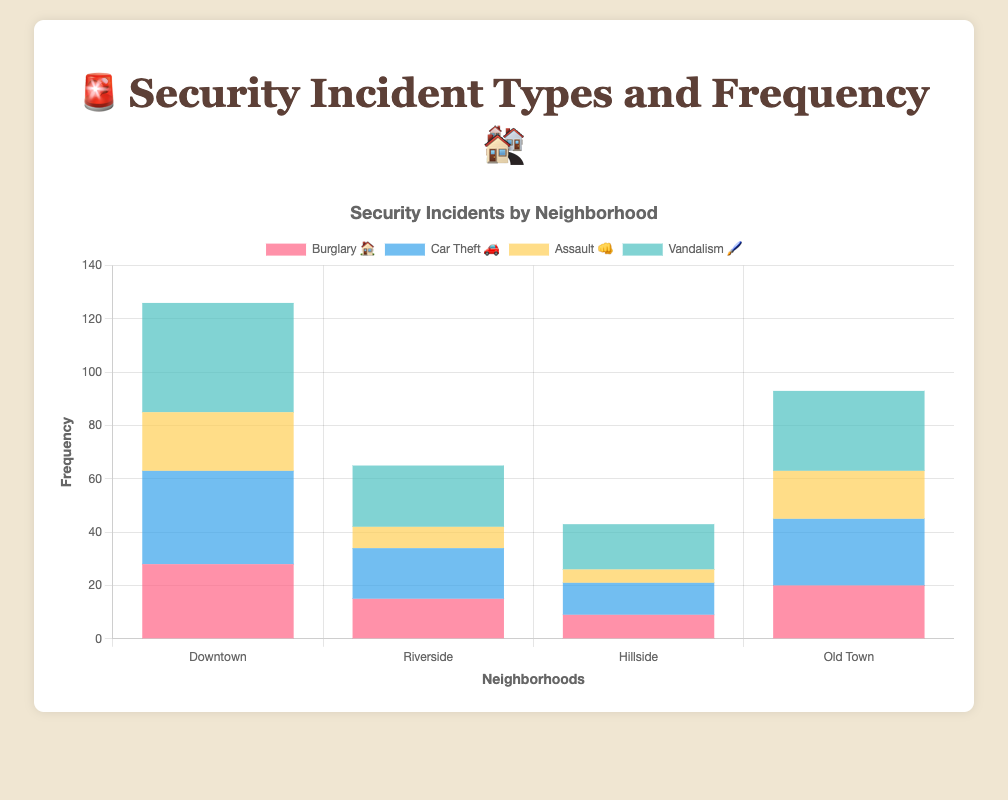Which neighborhood has the highest frequency of Vandalism 🖌️ incidents? The highest Vandalism incidents can be observed by comparing the bar lengths under the "Vandalism 🖌️" category across all neighborhoods. Downtown has the longest bar in this category.
Answer: Downtown What is the total number of incidents in Downtown? Sum the frequencies of all incident types in Downtown: Burglary (28) + Car Theft (35) + Assault (22) + Vandalism (41). The total is 28 + 35 + 22 + 41 = 126.
Answer: 126 Which incident type has the lowest frequency in Riverside? By comparing the bar lengths for all incident types in Riverside, we see that Assault incidents have the lowest bar.
Answer: Assault 👊 How does the frequency of Car Theft 🚗 in Old Town compare to Hillside? Look at the bar lengths for Car Theft incidents in both Old Town and Hillside. Old Town has a higher bar for Car Theft incidents than Hillside. Specifically, Old Town has 25, whereas Hillside has 12.
Answer: Old Town has more Which neighborhood has the fewest total security incidents? Sum the frequencies of all incidents for each neighborhood and compare the totals: Downtown (126), Riverside (65), Hillside (43), Old Town (93). Hillside has the lowest total.
Answer: Hillside How many more Vandalism 🖌️ incidents are there in Riverside compared to Hillside? Compare the Vandalism incident bars in Riverside and Hillside. Riverside has 23 Vandalism incidents, while Hillside has 17. The difference is 23 - 17 = 6.
Answer: 6 What is the average number of Burglary 🏠 incidents across all neighborhoods? Sum the frequency of Burglary incidents in all neighborhoods (28 + 15 + 9 + 20) and divide by the number of neighborhoods (4): (28 + 15 + 9 + 20)/4 = 72/4 = 18.
Answer: 18 Which incident type has the most overall frequencies across all neighborhoods? Sum the frequencies for each incident type across all neighborhoods: Burglary (28+15+9+20=72), Car Theft (35+19+12+25=91), Assault (22+8+5+18=53), Vandalism (41+23+17+30=111). Vandalism has the highest total.
Answer: Vandalism 🖌️ 